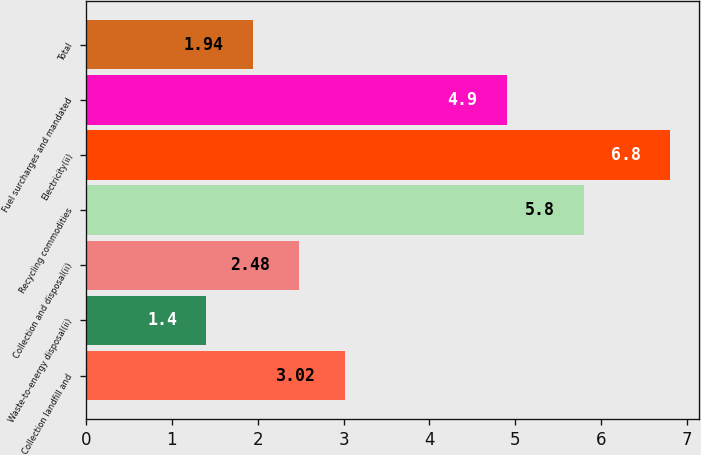Convert chart. <chart><loc_0><loc_0><loc_500><loc_500><bar_chart><fcel>Collection landfill and<fcel>Waste-to-energy disposal(ii)<fcel>Collection and disposal(ii)<fcel>Recycling commodities<fcel>Electricity(ii)<fcel>Fuel surcharges and mandated<fcel>Total<nl><fcel>3.02<fcel>1.4<fcel>2.48<fcel>5.8<fcel>6.8<fcel>4.9<fcel>1.94<nl></chart> 